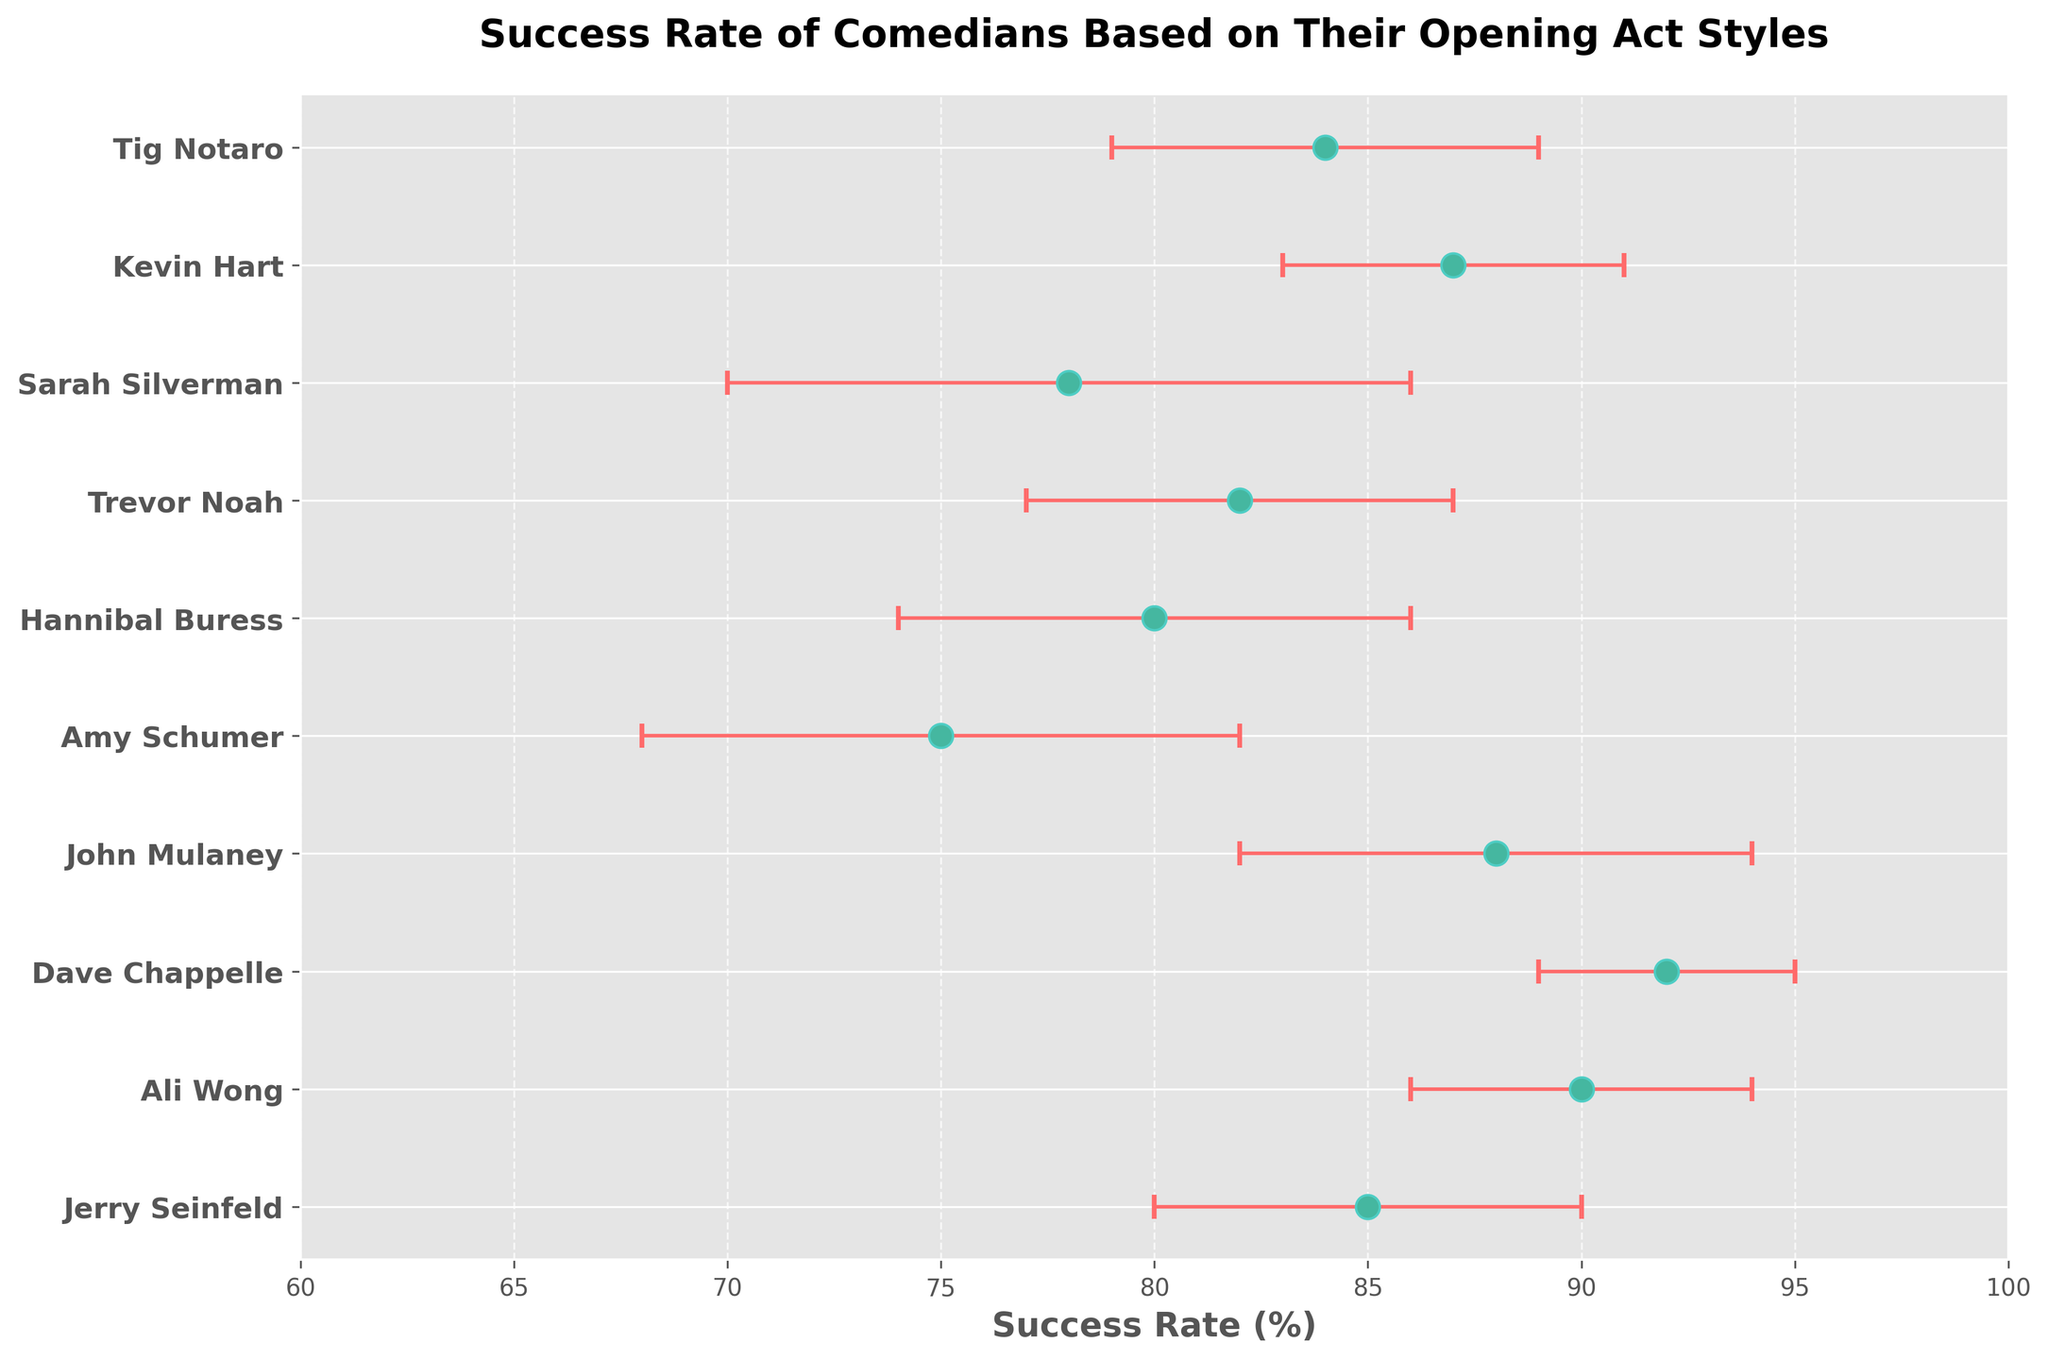What's the title of the figure? The title is usually positioned at the top of the figure, in bold and larger font size. In this case, it is written in bold.
Answer: Success Rate of Comedians Based on Their Opening Act Styles Which comedian has the highest success rate? The comedian with the highest data point along the X-axis represents the highest success rate. In this case, that point belongs to Dave Chappelle.
Answer: Dave Chappelle What is the average success rate of the comedians? To find the average, sum up the success rates and divide by the number of comedians: (85 + 90 + 92 + 88 + 75 + 80 + 82 + 78 + 87 + 84) / 10 = 841 / 10 = 84.1.
Answer: 84.1 Who has the largest error bar, and what is its value? Error bars indicate the variability of data. The comedian with the widest error bar is Amy Schumer, with an error value of 7.
Answer: Amy Schumer, 7 What is the common range of success rates shown in the figure? The X-axis range of success rates can be seen on the labels. For this figure, it spans from 60 to 100 percent.
Answer: 60% to 100% Which comedian has a lower success rate than Trevor Noah but higher than Sarah Silverman? By examining the data points between Trevor Noah's (82) and Sarah Silverman's (78) success rates, Tig Notaro is the one that fits this criterion with a success rate of 80.
Answer: Tig Notaro What are the strange colors used in the plot for the error bars and the data points? The colors can be observed directly on the plot. The error bars are colored in a light red while the data points have a turquoise-like color with darker turquoise outlines.
Answer: Light red for error bars and turquoise with dark turquoise outlines for data points Which comedian's success rate falls within the error range of Kevin Hart and Hannibal Buress? Kevin Hart's success rate is 87% with an error of 4, ranging from 83% to 91%. Hannibal Buress's success rate is 80% with an error of 6, ranging from 74% to 86%. John Mulaney’s success rate of 88% lies within these ranges.
Answer: John Mulaney What is the combined error range for Jerry Seinfeld's and Ali Wong's success rates? Adding the error values gives us 5 for Jerry Seinfeld and 4 for Ali Wong, resulting in 5 + 4 = 9.
Answer: 9 